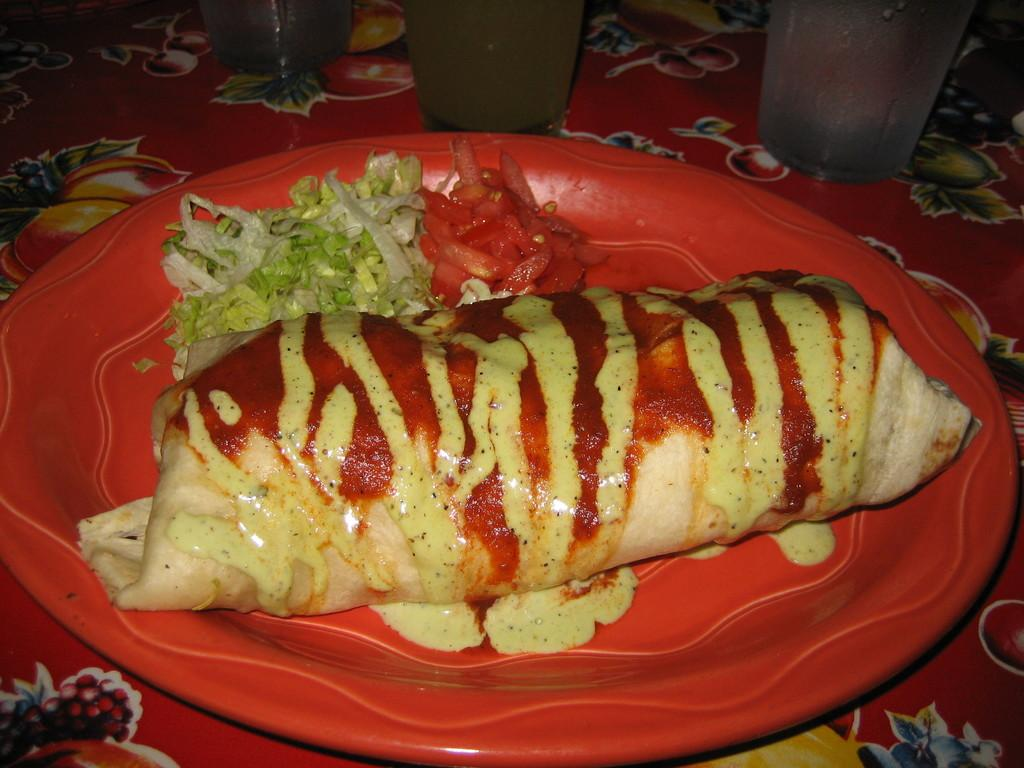How many eggs are in the nest that is floating in the cloud in the image? There is no nest, cloud, or eggs present in the image. 